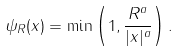<formula> <loc_0><loc_0><loc_500><loc_500>\psi _ { R } ( x ) = \min \left ( 1 , \frac { R ^ { a } } { | x | ^ { a } } \right ) .</formula> 